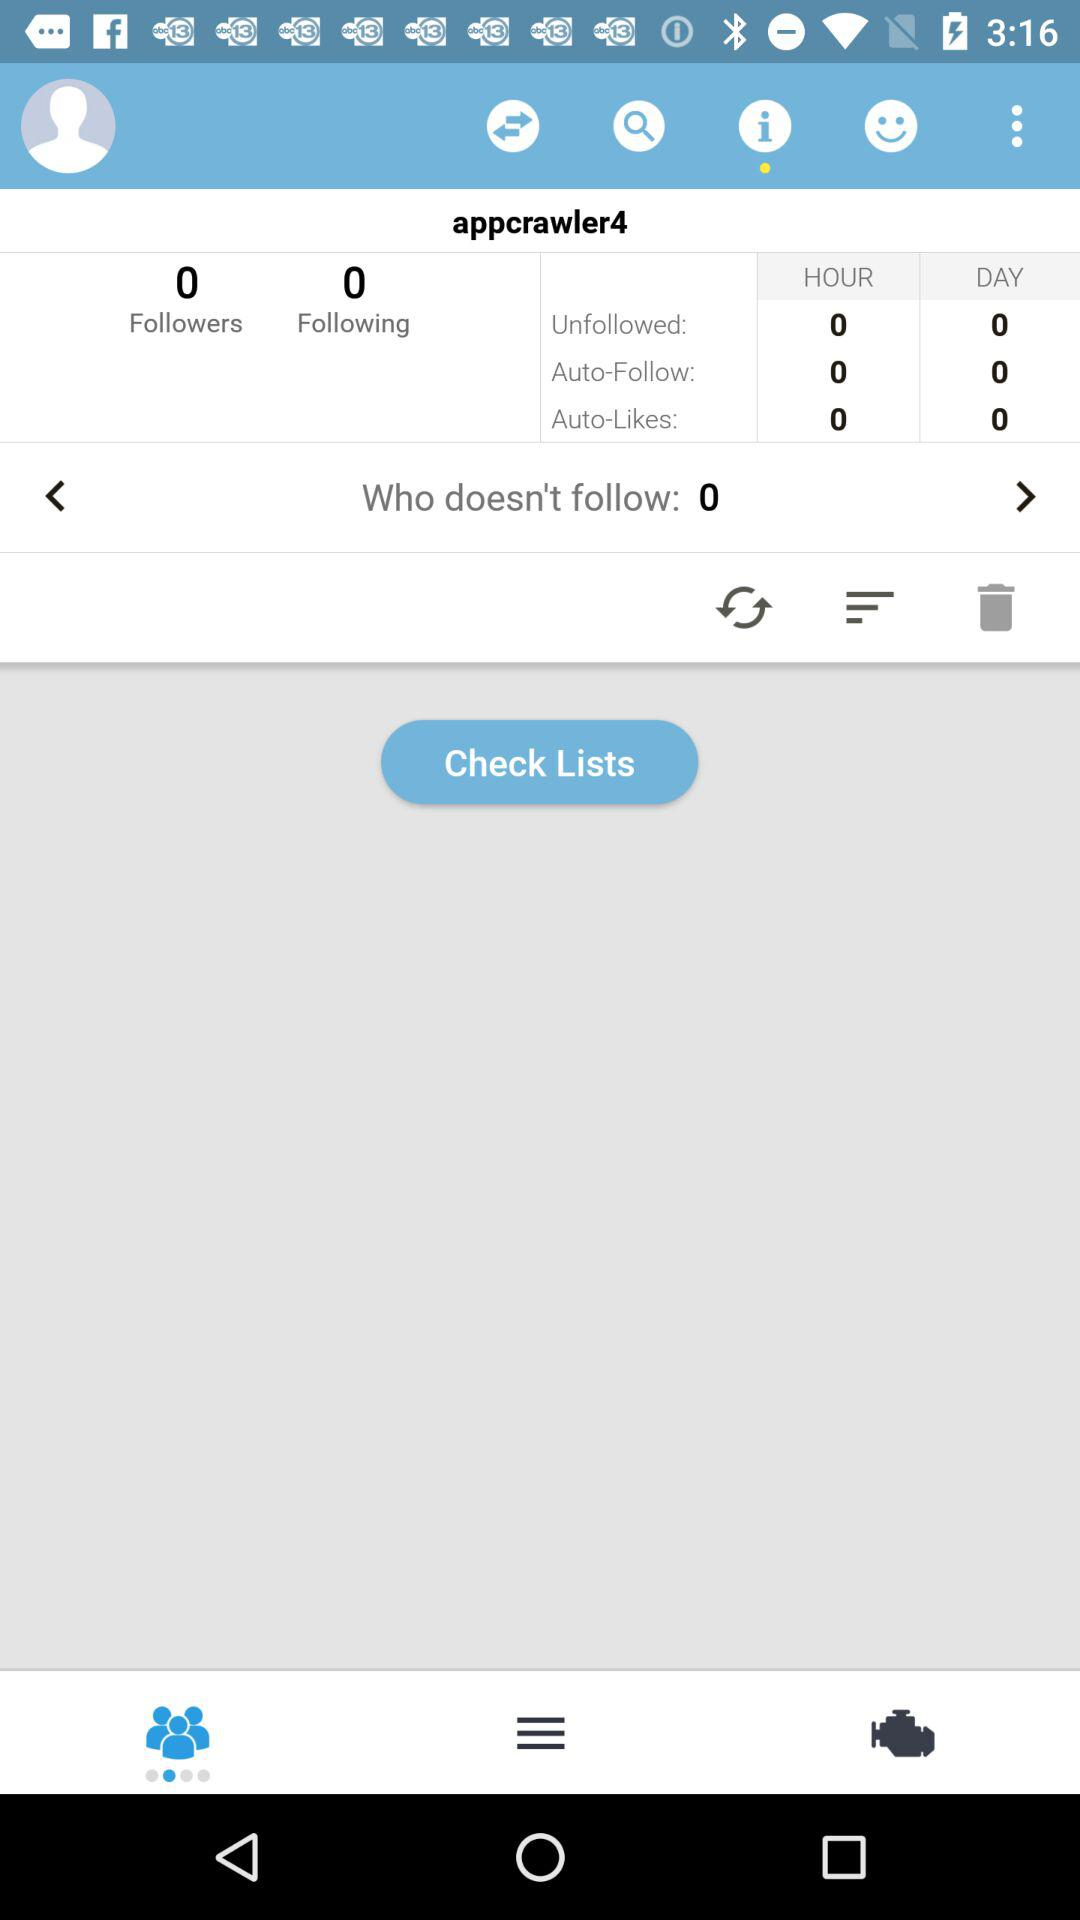What's the username? The username is "appcrawler4". 